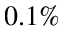<formula> <loc_0><loc_0><loc_500><loc_500>0 . 1 \%</formula> 